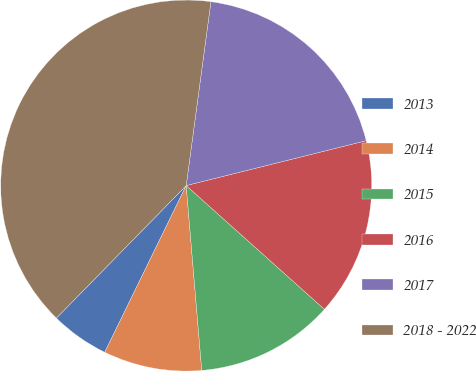Convert chart to OTSL. <chart><loc_0><loc_0><loc_500><loc_500><pie_chart><fcel>2013<fcel>2014<fcel>2015<fcel>2016<fcel>2017<fcel>2018 - 2022<nl><fcel>5.1%<fcel>8.57%<fcel>12.04%<fcel>15.51%<fcel>18.98%<fcel>39.79%<nl></chart> 